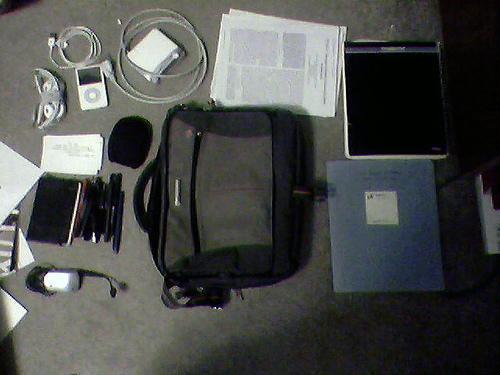How many ipods are in the picture?
Give a very brief answer. 1. 